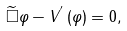Convert formula to latex. <formula><loc_0><loc_0><loc_500><loc_500>\widetilde { { \Box } } \varphi - V ^ { ^ { \prime } } \left ( \varphi \right ) = 0 ,</formula> 